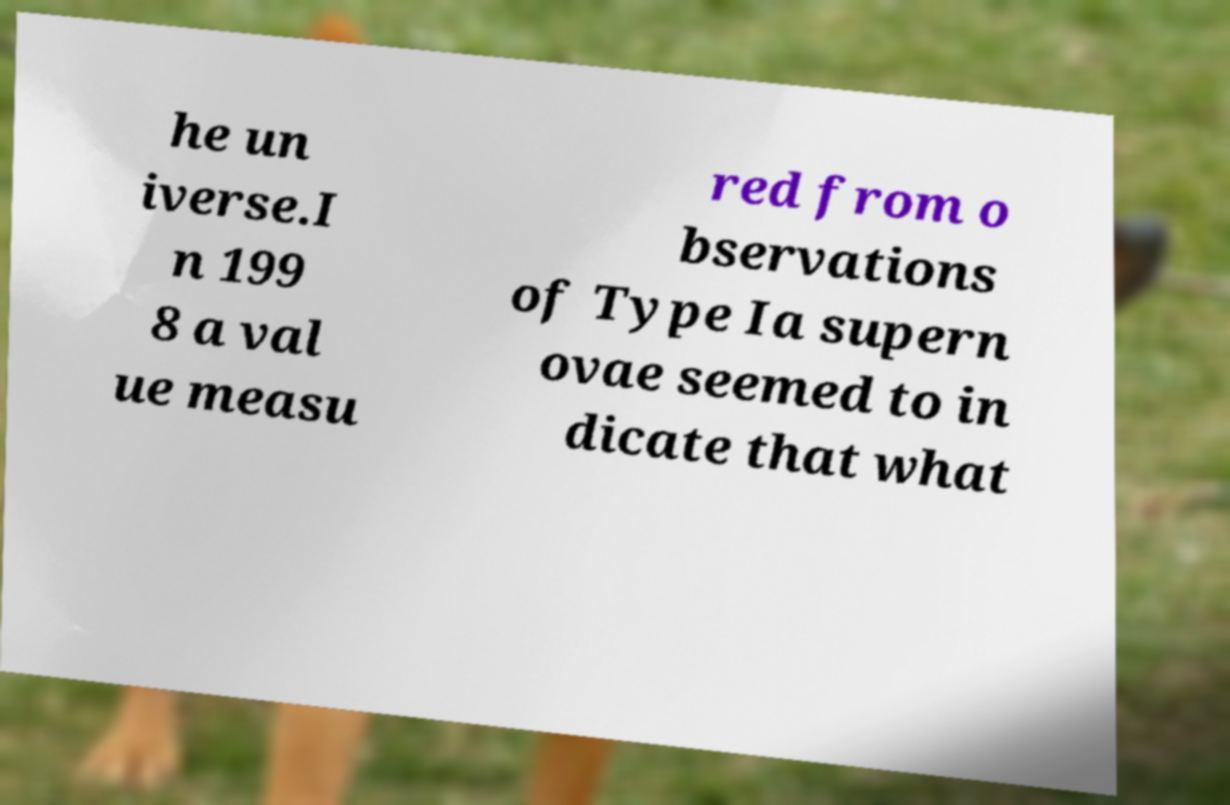Could you extract and type out the text from this image? he un iverse.I n 199 8 a val ue measu red from o bservations of Type Ia supern ovae seemed to in dicate that what 